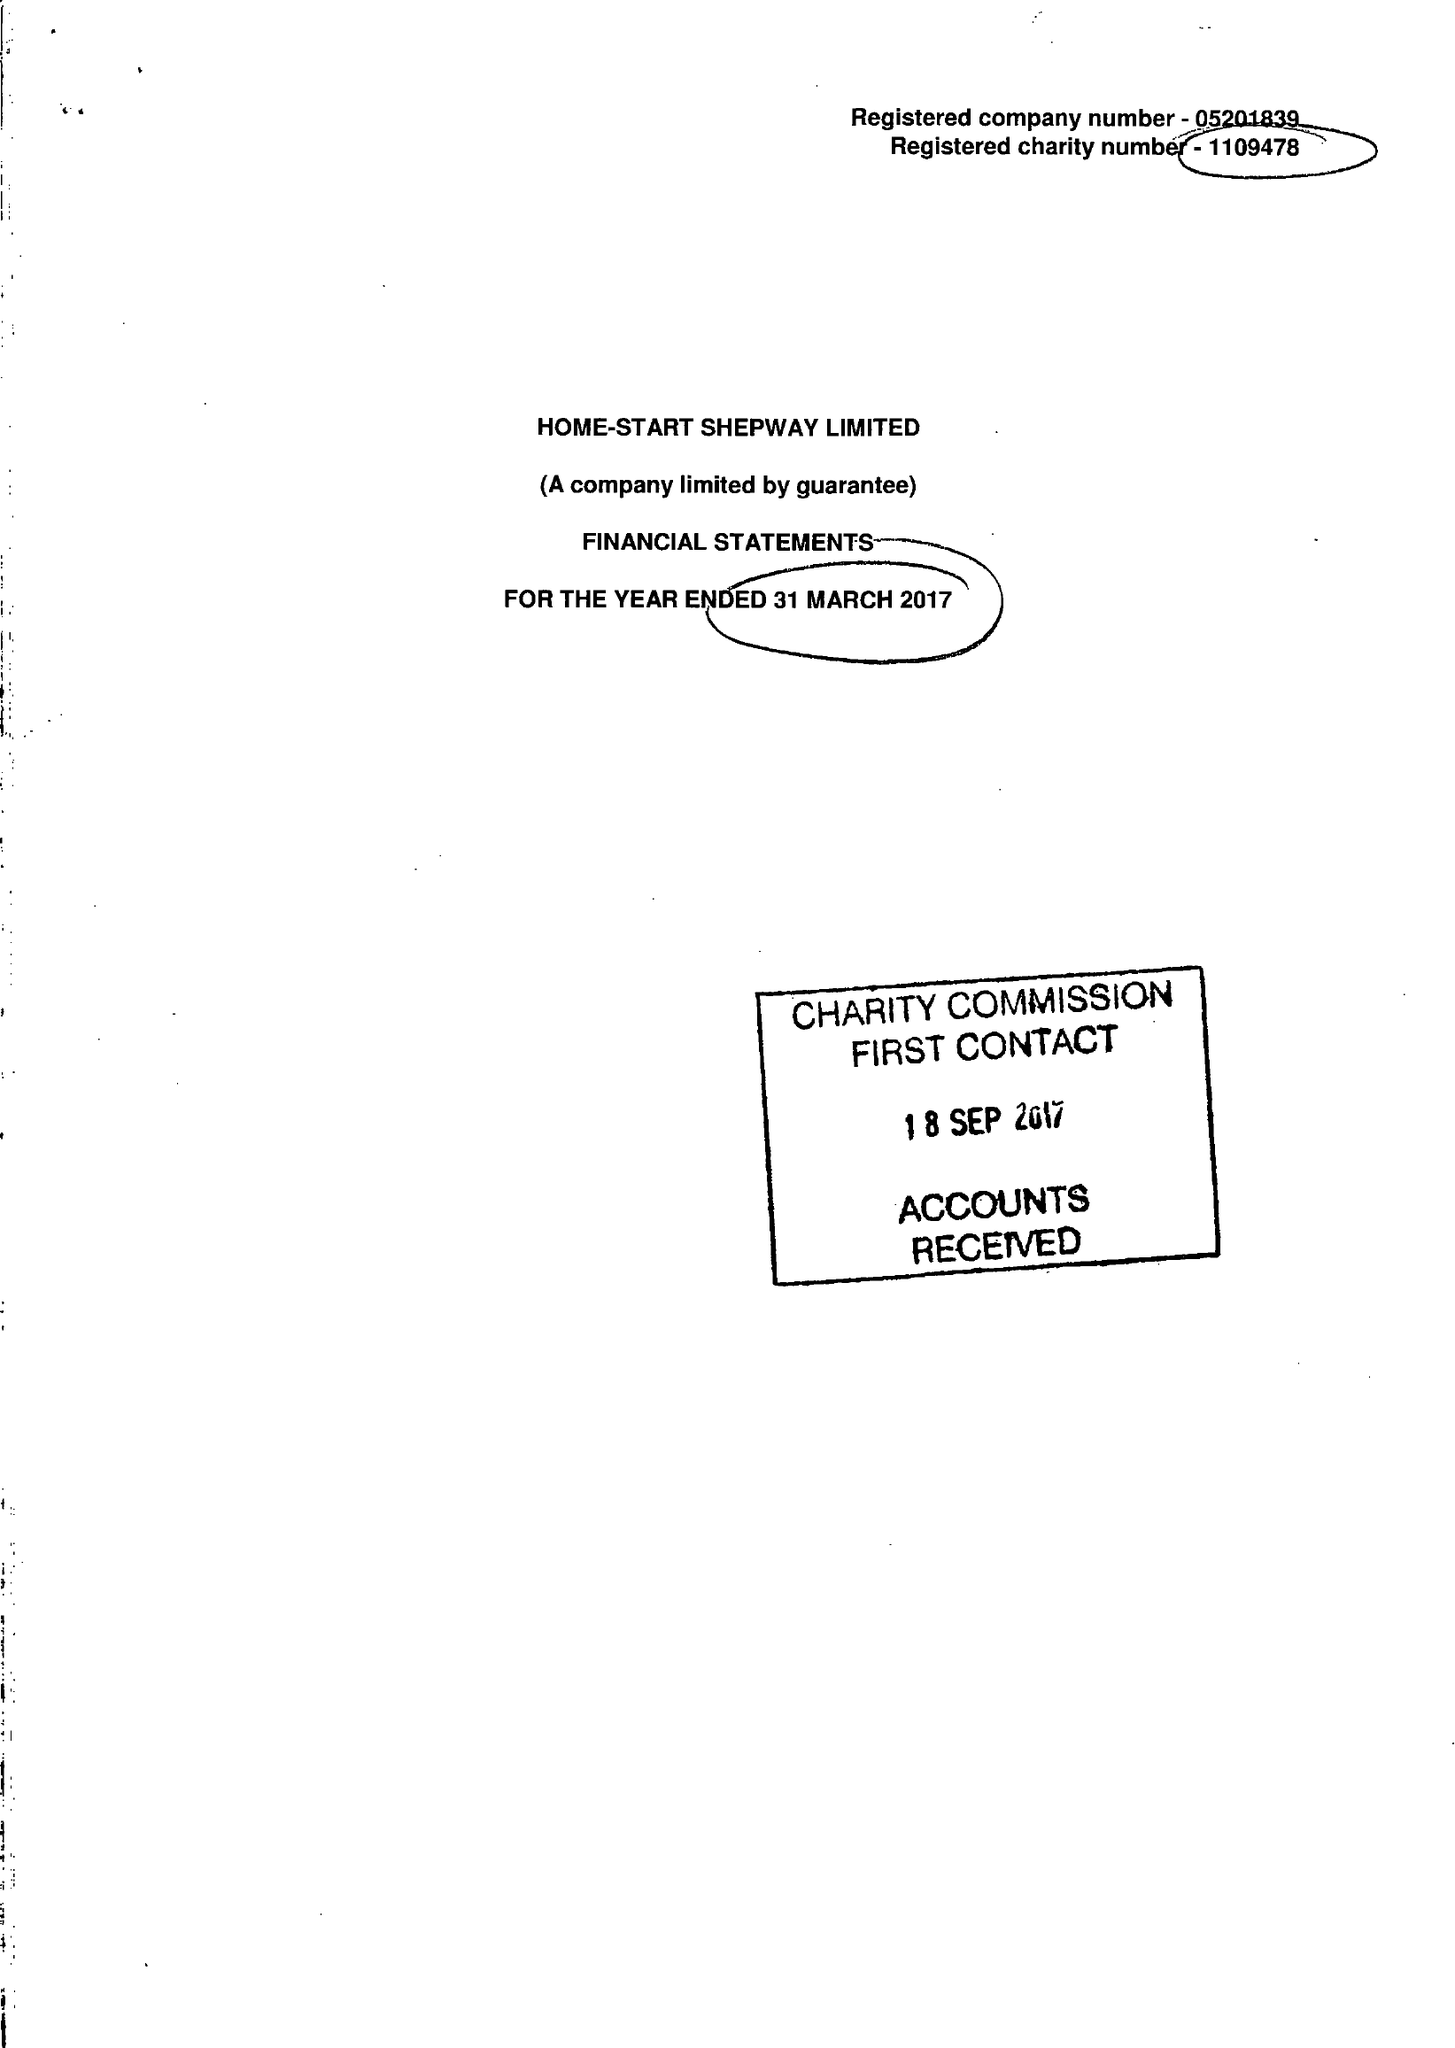What is the value for the report_date?
Answer the question using a single word or phrase. 2017-03-31 